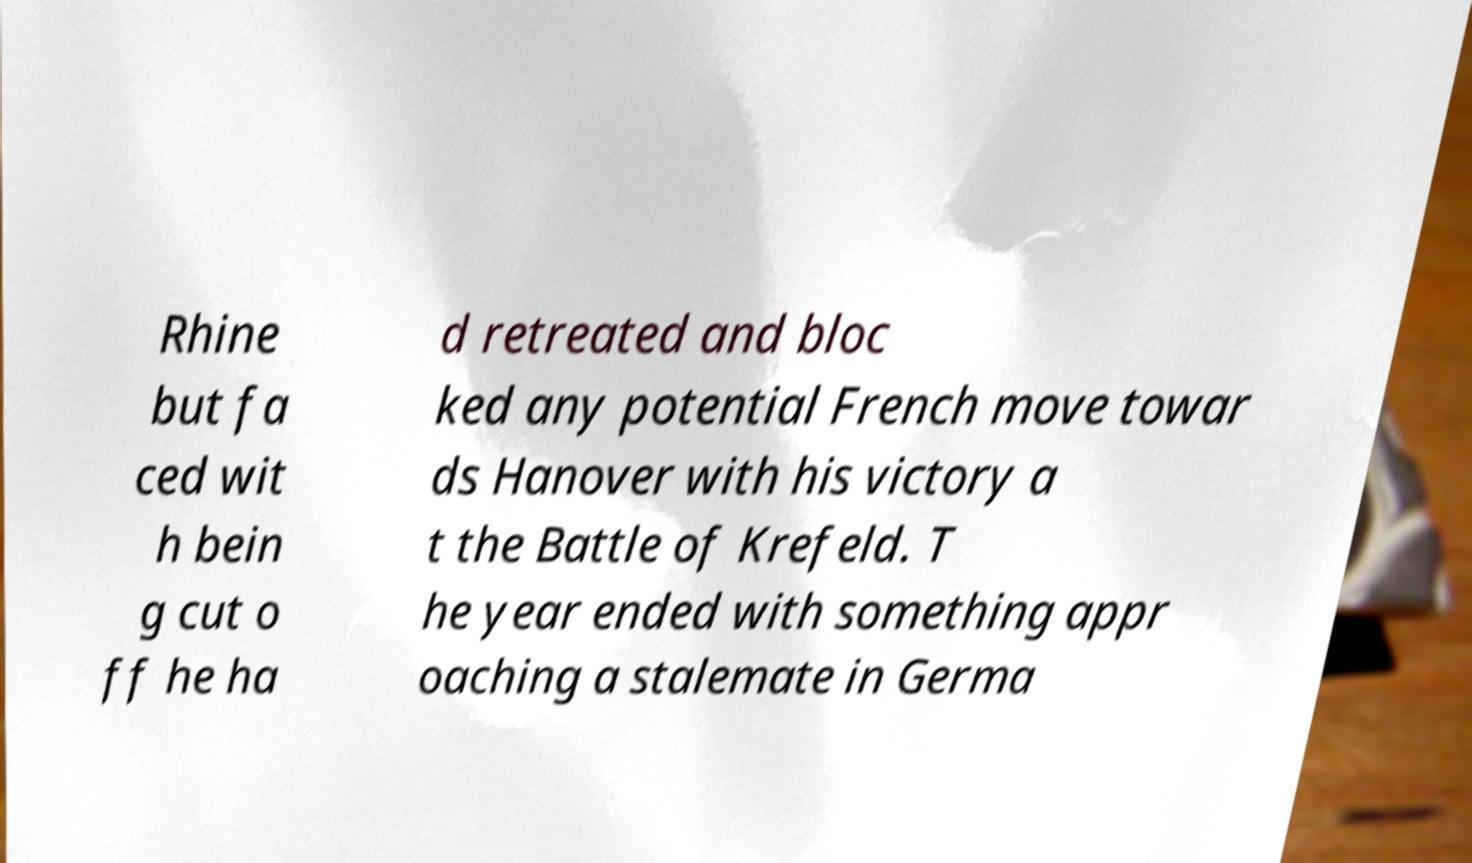Can you accurately transcribe the text from the provided image for me? Rhine but fa ced wit h bein g cut o ff he ha d retreated and bloc ked any potential French move towar ds Hanover with his victory a t the Battle of Krefeld. T he year ended with something appr oaching a stalemate in Germa 